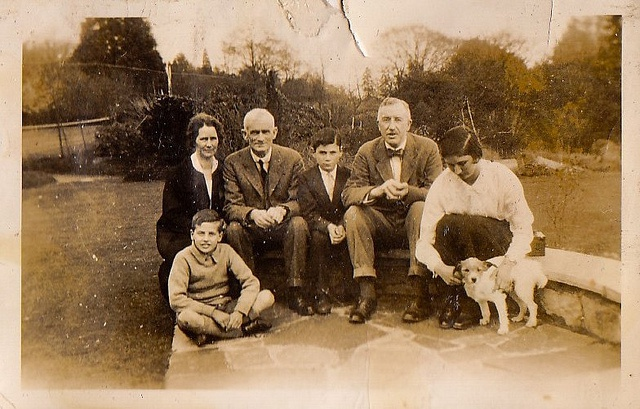Describe the objects in this image and their specific colors. I can see people in tan, maroon, and black tones, people in tan, maroon, black, and gray tones, people in tan, black, maroon, and gray tones, people in tan and black tones, and bench in tan, olive, and maroon tones in this image. 